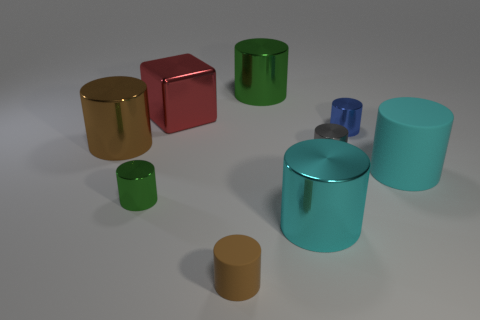Is there a tiny blue object made of the same material as the gray object? Yes, there is a small blue object that appears to have a similar reflective material as the larger gray object, likely indicating they are made from the same or very similar substances. 